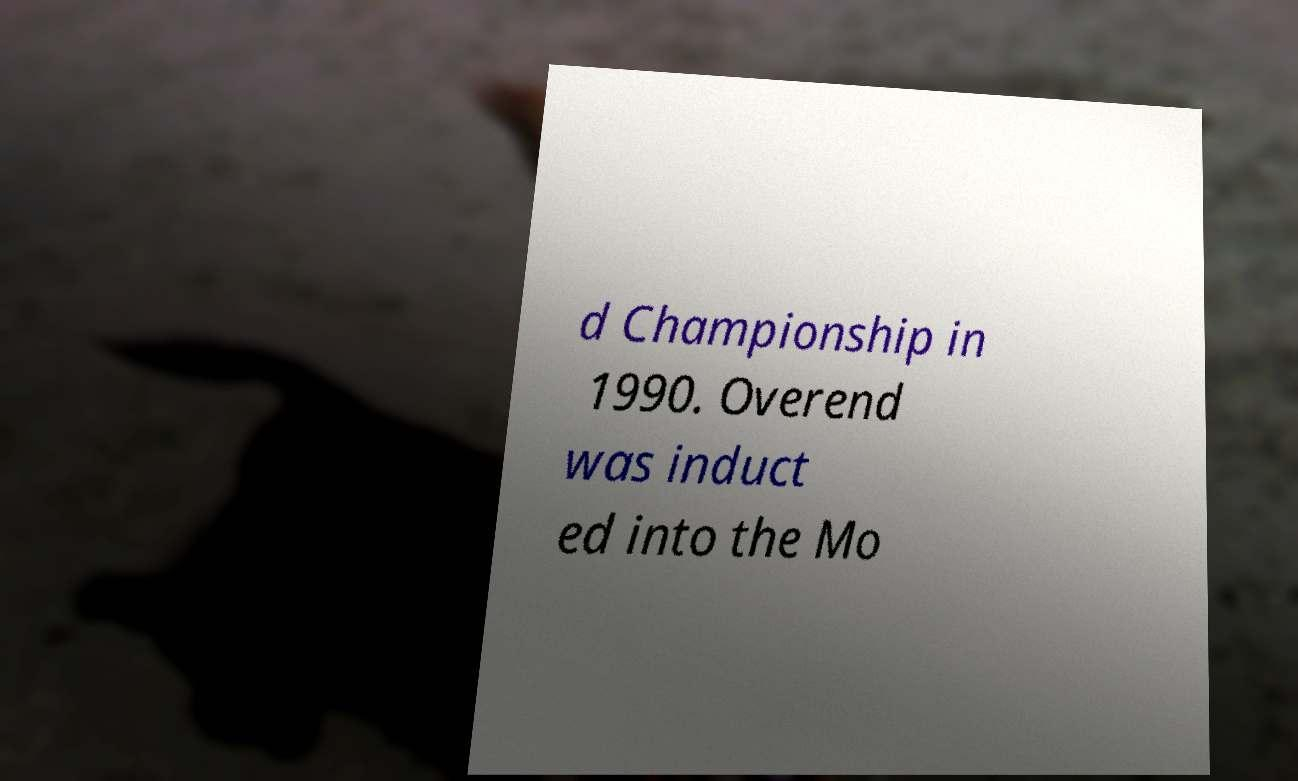Can you accurately transcribe the text from the provided image for me? d Championship in 1990. Overend was induct ed into the Mo 